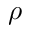<formula> <loc_0><loc_0><loc_500><loc_500>\rho</formula> 